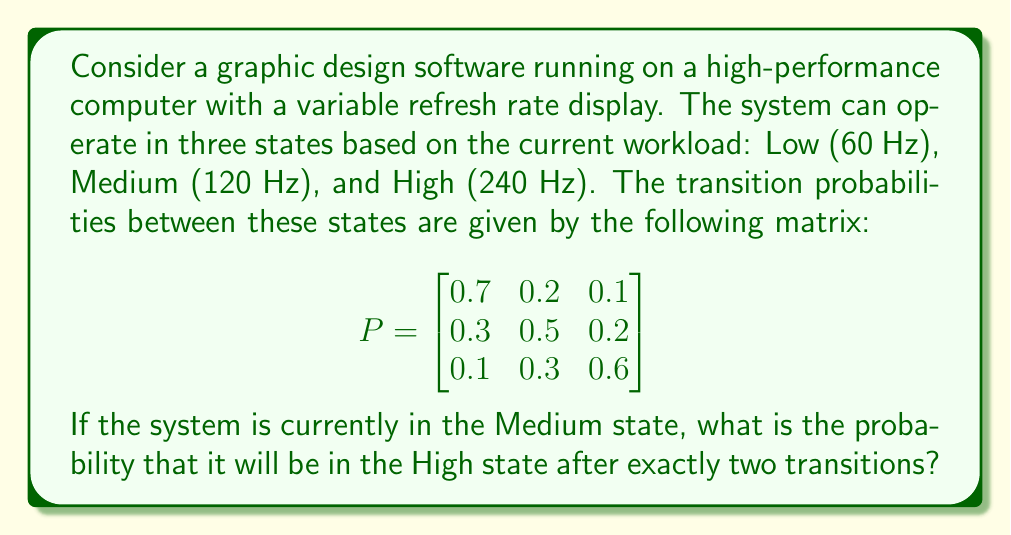Give your solution to this math problem. To solve this problem, we need to use the Chapman-Kolmogorov equations for Markov chains. We're interested in the probability of going from the Medium state to the High state in exactly two steps.

Let's break it down step-by-step:

1) First, we need to calculate $P^2$ (the transition matrix raised to the power of 2). This gives us the probabilities of transitioning between states in exactly two steps.

   $$P^2 = P \times P = \begin{bmatrix}
   0.7 & 0.2 & 0.1 \\
   0.3 & 0.5 & 0.2 \\
   0.1 & 0.3 & 0.6
   \end{bmatrix} \times \begin{bmatrix}
   0.7 & 0.2 & 0.1 \\
   0.3 & 0.5 & 0.2 \\
   0.1 & 0.3 & 0.6
   \end{bmatrix}$$

2) Performing the matrix multiplication:

   $$P^2 = \begin{bmatrix}
   0.56 & 0.29 & 0.15 \\
   0.37 & 0.41 & 0.22 \\
   0.22 & 0.39 & 0.39
   \end{bmatrix}$$

3) We're interested in the probability of going from the Medium state (state 2) to the High state (state 3) in two steps. This corresponds to the element in the second row, third column of $P^2$.

4) From our calculation, we can see that this probability is 0.22.

Therefore, the probability that the system will be in the High state after exactly two transitions, given that it starts in the Medium state, is 0.22 or 22%.
Answer: 0.22 